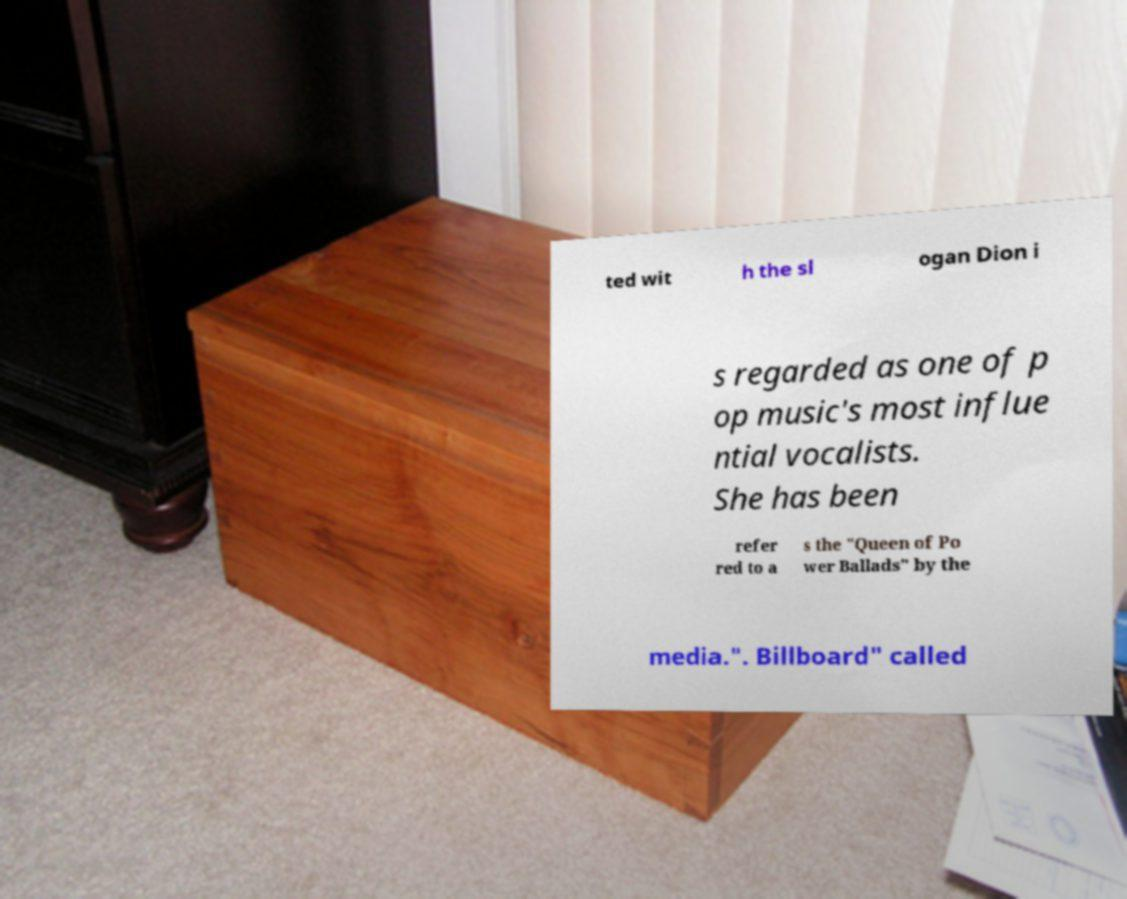Please read and relay the text visible in this image. What does it say? ted wit h the sl ogan Dion i s regarded as one of p op music's most influe ntial vocalists. She has been refer red to a s the "Queen of Po wer Ballads" by the media.". Billboard" called 